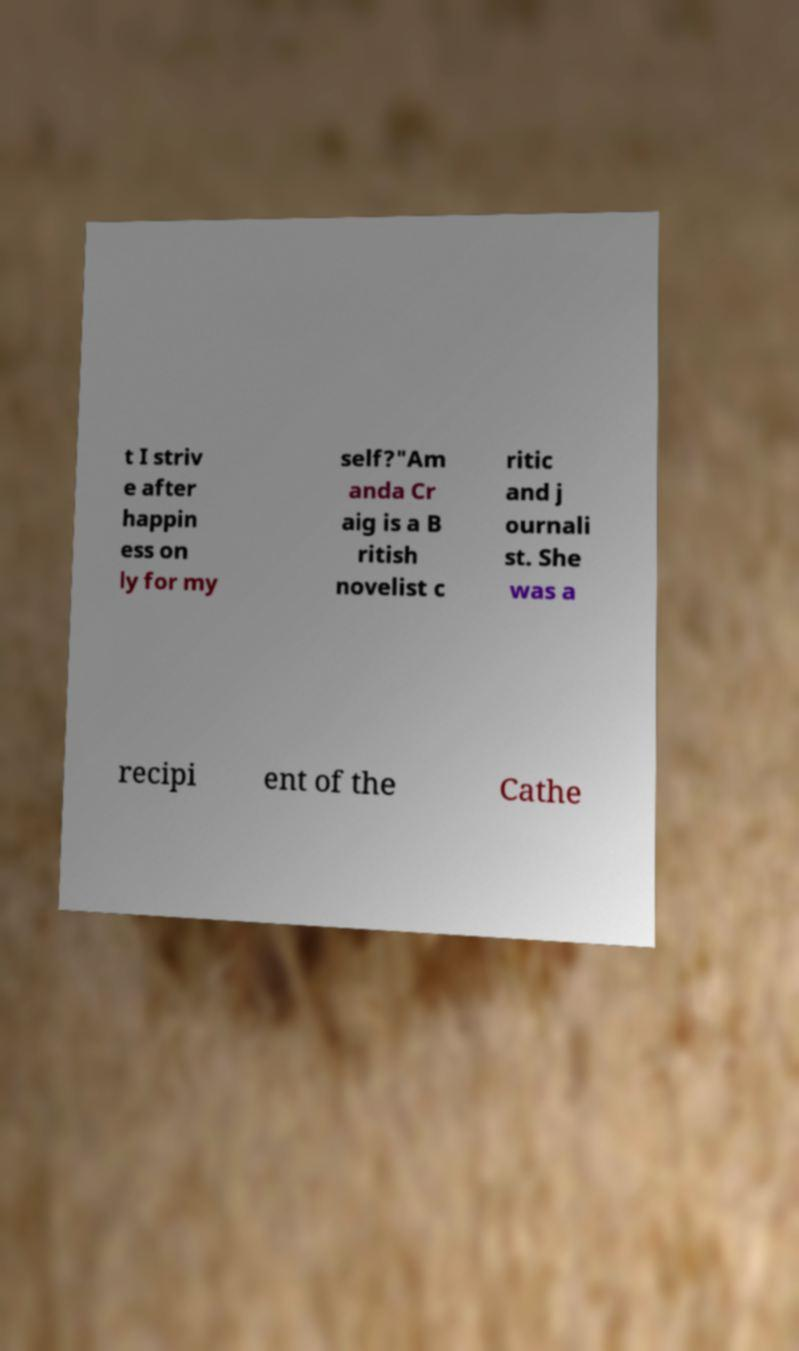There's text embedded in this image that I need extracted. Can you transcribe it verbatim? t I striv e after happin ess on ly for my self?"Am anda Cr aig is a B ritish novelist c ritic and j ournali st. She was a recipi ent of the Cathe 